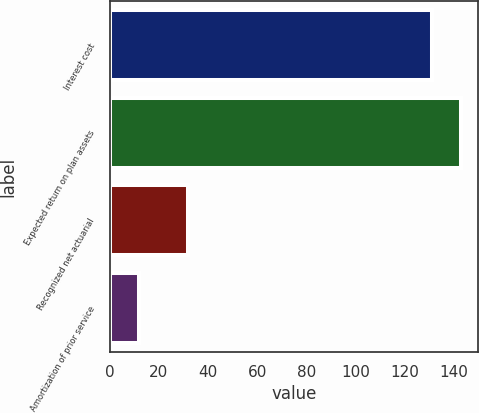Convert chart to OTSL. <chart><loc_0><loc_0><loc_500><loc_500><bar_chart><fcel>Interest cost<fcel>Expected return on plan assets<fcel>Recognized net actuarial<fcel>Amortization of prior service<nl><fcel>131<fcel>142.9<fcel>32<fcel>12<nl></chart> 